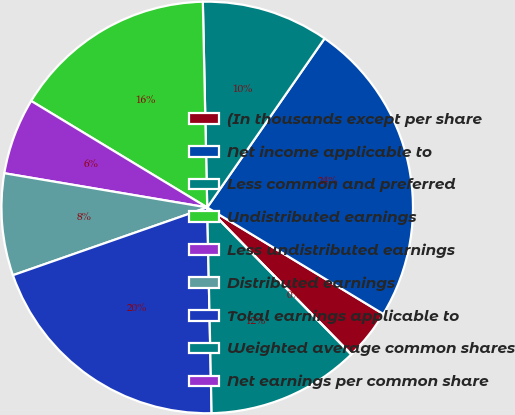Convert chart. <chart><loc_0><loc_0><loc_500><loc_500><pie_chart><fcel>(In thousands except per share<fcel>Net income applicable to<fcel>Less common and preferred<fcel>Undistributed earnings<fcel>Less undistributed earnings<fcel>Distributed earnings<fcel>Total earnings applicable to<fcel>Weighted average common shares<fcel>Net earnings per common share<nl><fcel>4.0%<fcel>24.0%<fcel>10.0%<fcel>16.0%<fcel>6.0%<fcel>8.0%<fcel>20.0%<fcel>12.0%<fcel>0.0%<nl></chart> 